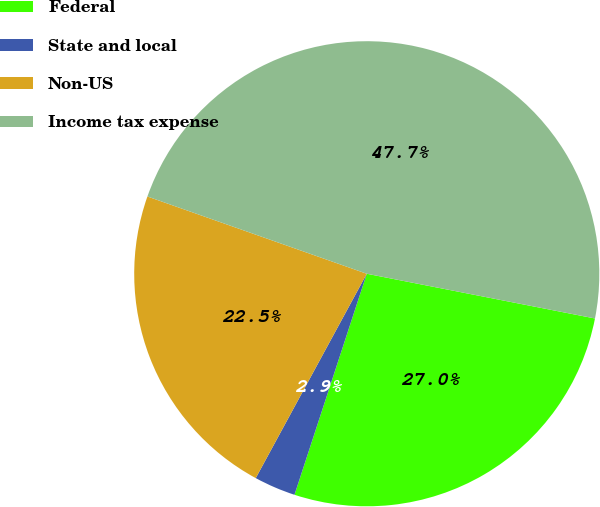Convert chart to OTSL. <chart><loc_0><loc_0><loc_500><loc_500><pie_chart><fcel>Federal<fcel>State and local<fcel>Non-US<fcel>Income tax expense<nl><fcel>26.95%<fcel>2.89%<fcel>22.47%<fcel>47.69%<nl></chart> 